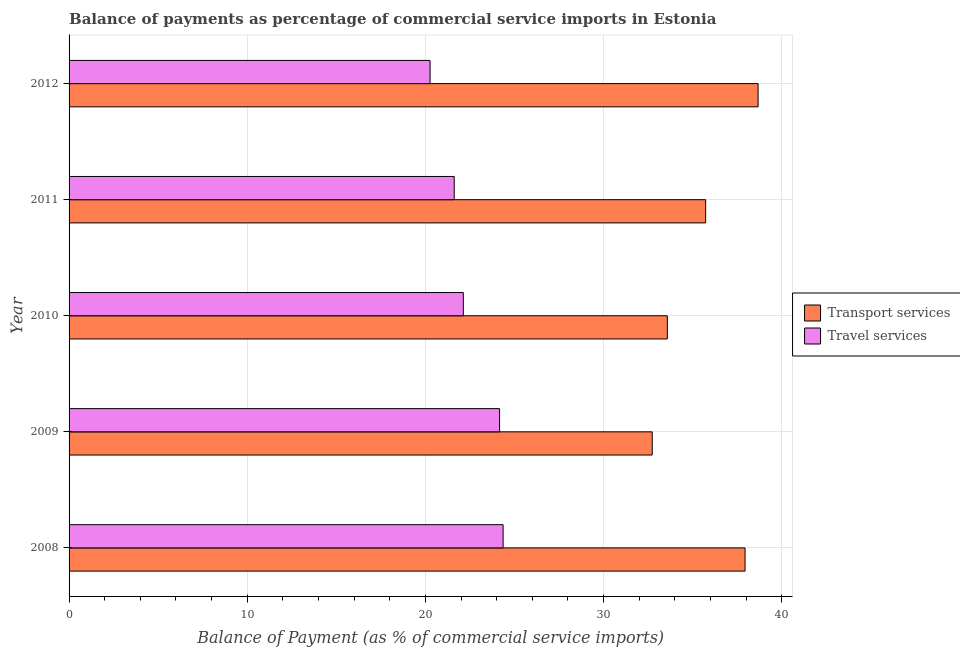Are the number of bars per tick equal to the number of legend labels?
Provide a succinct answer. Yes. How many bars are there on the 3rd tick from the top?
Offer a terse response. 2. How many bars are there on the 3rd tick from the bottom?
Your response must be concise. 2. What is the label of the 5th group of bars from the top?
Keep it short and to the point. 2008. What is the balance of payments of transport services in 2011?
Give a very brief answer. 35.73. Across all years, what is the maximum balance of payments of travel services?
Your answer should be very brief. 24.36. Across all years, what is the minimum balance of payments of travel services?
Ensure brevity in your answer.  20.26. What is the total balance of payments of travel services in the graph?
Your answer should be very brief. 112.52. What is the difference between the balance of payments of transport services in 2008 and that in 2011?
Offer a terse response. 2.21. What is the difference between the balance of payments of travel services in 2011 and the balance of payments of transport services in 2012?
Make the answer very short. -17.06. What is the average balance of payments of transport services per year?
Your answer should be very brief. 35.73. In the year 2011, what is the difference between the balance of payments of transport services and balance of payments of travel services?
Ensure brevity in your answer.  14.11. In how many years, is the balance of payments of transport services greater than 32 %?
Your answer should be very brief. 5. Is the balance of payments of travel services in 2008 less than that in 2012?
Your response must be concise. No. Is the difference between the balance of payments of transport services in 2010 and 2011 greater than the difference between the balance of payments of travel services in 2010 and 2011?
Provide a succinct answer. No. What is the difference between the highest and the second highest balance of payments of transport services?
Ensure brevity in your answer.  0.73. In how many years, is the balance of payments of transport services greater than the average balance of payments of transport services taken over all years?
Your response must be concise. 2. Is the sum of the balance of payments of transport services in 2009 and 2010 greater than the maximum balance of payments of travel services across all years?
Your response must be concise. Yes. What does the 2nd bar from the top in 2008 represents?
Provide a short and direct response. Transport services. What does the 1st bar from the bottom in 2012 represents?
Your response must be concise. Transport services. How many bars are there?
Make the answer very short. 10. Are all the bars in the graph horizontal?
Your answer should be very brief. Yes. What is the difference between two consecutive major ticks on the X-axis?
Offer a terse response. 10. Are the values on the major ticks of X-axis written in scientific E-notation?
Keep it short and to the point. No. Does the graph contain any zero values?
Keep it short and to the point. No. How are the legend labels stacked?
Make the answer very short. Vertical. What is the title of the graph?
Offer a terse response. Balance of payments as percentage of commercial service imports in Estonia. Does "External balance on goods" appear as one of the legend labels in the graph?
Provide a short and direct response. No. What is the label or title of the X-axis?
Ensure brevity in your answer.  Balance of Payment (as % of commercial service imports). What is the Balance of Payment (as % of commercial service imports) of Transport services in 2008?
Your response must be concise. 37.94. What is the Balance of Payment (as % of commercial service imports) of Travel services in 2008?
Your response must be concise. 24.36. What is the Balance of Payment (as % of commercial service imports) in Transport services in 2009?
Your answer should be very brief. 32.73. What is the Balance of Payment (as % of commercial service imports) of Travel services in 2009?
Ensure brevity in your answer.  24.16. What is the Balance of Payment (as % of commercial service imports) in Transport services in 2010?
Ensure brevity in your answer.  33.58. What is the Balance of Payment (as % of commercial service imports) of Travel services in 2010?
Your response must be concise. 22.13. What is the Balance of Payment (as % of commercial service imports) in Transport services in 2011?
Provide a succinct answer. 35.73. What is the Balance of Payment (as % of commercial service imports) in Travel services in 2011?
Your answer should be very brief. 21.62. What is the Balance of Payment (as % of commercial service imports) of Transport services in 2012?
Your answer should be compact. 38.67. What is the Balance of Payment (as % of commercial service imports) in Travel services in 2012?
Your answer should be very brief. 20.26. Across all years, what is the maximum Balance of Payment (as % of commercial service imports) of Transport services?
Provide a succinct answer. 38.67. Across all years, what is the maximum Balance of Payment (as % of commercial service imports) in Travel services?
Give a very brief answer. 24.36. Across all years, what is the minimum Balance of Payment (as % of commercial service imports) of Transport services?
Offer a very short reply. 32.73. Across all years, what is the minimum Balance of Payment (as % of commercial service imports) in Travel services?
Keep it short and to the point. 20.26. What is the total Balance of Payment (as % of commercial service imports) in Transport services in the graph?
Offer a very short reply. 178.64. What is the total Balance of Payment (as % of commercial service imports) of Travel services in the graph?
Keep it short and to the point. 112.52. What is the difference between the Balance of Payment (as % of commercial service imports) of Transport services in 2008 and that in 2009?
Offer a very short reply. 5.21. What is the difference between the Balance of Payment (as % of commercial service imports) in Travel services in 2008 and that in 2009?
Ensure brevity in your answer.  0.2. What is the difference between the Balance of Payment (as % of commercial service imports) of Transport services in 2008 and that in 2010?
Ensure brevity in your answer.  4.36. What is the difference between the Balance of Payment (as % of commercial service imports) of Travel services in 2008 and that in 2010?
Keep it short and to the point. 2.23. What is the difference between the Balance of Payment (as % of commercial service imports) of Transport services in 2008 and that in 2011?
Provide a short and direct response. 2.21. What is the difference between the Balance of Payment (as % of commercial service imports) of Travel services in 2008 and that in 2011?
Keep it short and to the point. 2.75. What is the difference between the Balance of Payment (as % of commercial service imports) in Transport services in 2008 and that in 2012?
Give a very brief answer. -0.73. What is the difference between the Balance of Payment (as % of commercial service imports) of Transport services in 2009 and that in 2010?
Ensure brevity in your answer.  -0.85. What is the difference between the Balance of Payment (as % of commercial service imports) of Travel services in 2009 and that in 2010?
Provide a succinct answer. 2.03. What is the difference between the Balance of Payment (as % of commercial service imports) in Transport services in 2009 and that in 2011?
Ensure brevity in your answer.  -3. What is the difference between the Balance of Payment (as % of commercial service imports) of Travel services in 2009 and that in 2011?
Offer a terse response. 2.55. What is the difference between the Balance of Payment (as % of commercial service imports) of Transport services in 2009 and that in 2012?
Make the answer very short. -5.94. What is the difference between the Balance of Payment (as % of commercial service imports) of Travel services in 2009 and that in 2012?
Make the answer very short. 3.9. What is the difference between the Balance of Payment (as % of commercial service imports) of Transport services in 2010 and that in 2011?
Your response must be concise. -2.15. What is the difference between the Balance of Payment (as % of commercial service imports) of Travel services in 2010 and that in 2011?
Provide a succinct answer. 0.51. What is the difference between the Balance of Payment (as % of commercial service imports) in Transport services in 2010 and that in 2012?
Give a very brief answer. -5.09. What is the difference between the Balance of Payment (as % of commercial service imports) of Travel services in 2010 and that in 2012?
Your response must be concise. 1.87. What is the difference between the Balance of Payment (as % of commercial service imports) in Transport services in 2011 and that in 2012?
Make the answer very short. -2.94. What is the difference between the Balance of Payment (as % of commercial service imports) of Travel services in 2011 and that in 2012?
Provide a succinct answer. 1.35. What is the difference between the Balance of Payment (as % of commercial service imports) in Transport services in 2008 and the Balance of Payment (as % of commercial service imports) in Travel services in 2009?
Offer a very short reply. 13.78. What is the difference between the Balance of Payment (as % of commercial service imports) of Transport services in 2008 and the Balance of Payment (as % of commercial service imports) of Travel services in 2010?
Your answer should be very brief. 15.81. What is the difference between the Balance of Payment (as % of commercial service imports) of Transport services in 2008 and the Balance of Payment (as % of commercial service imports) of Travel services in 2011?
Offer a terse response. 16.32. What is the difference between the Balance of Payment (as % of commercial service imports) of Transport services in 2008 and the Balance of Payment (as % of commercial service imports) of Travel services in 2012?
Offer a terse response. 17.68. What is the difference between the Balance of Payment (as % of commercial service imports) in Transport services in 2009 and the Balance of Payment (as % of commercial service imports) in Travel services in 2010?
Ensure brevity in your answer.  10.6. What is the difference between the Balance of Payment (as % of commercial service imports) in Transport services in 2009 and the Balance of Payment (as % of commercial service imports) in Travel services in 2011?
Provide a short and direct response. 11.11. What is the difference between the Balance of Payment (as % of commercial service imports) in Transport services in 2009 and the Balance of Payment (as % of commercial service imports) in Travel services in 2012?
Your answer should be compact. 12.47. What is the difference between the Balance of Payment (as % of commercial service imports) in Transport services in 2010 and the Balance of Payment (as % of commercial service imports) in Travel services in 2011?
Offer a terse response. 11.96. What is the difference between the Balance of Payment (as % of commercial service imports) in Transport services in 2010 and the Balance of Payment (as % of commercial service imports) in Travel services in 2012?
Provide a short and direct response. 13.32. What is the difference between the Balance of Payment (as % of commercial service imports) in Transport services in 2011 and the Balance of Payment (as % of commercial service imports) in Travel services in 2012?
Provide a short and direct response. 15.47. What is the average Balance of Payment (as % of commercial service imports) of Transport services per year?
Keep it short and to the point. 35.73. What is the average Balance of Payment (as % of commercial service imports) of Travel services per year?
Make the answer very short. 22.5. In the year 2008, what is the difference between the Balance of Payment (as % of commercial service imports) of Transport services and Balance of Payment (as % of commercial service imports) of Travel services?
Provide a succinct answer. 13.58. In the year 2009, what is the difference between the Balance of Payment (as % of commercial service imports) of Transport services and Balance of Payment (as % of commercial service imports) of Travel services?
Ensure brevity in your answer.  8.57. In the year 2010, what is the difference between the Balance of Payment (as % of commercial service imports) of Transport services and Balance of Payment (as % of commercial service imports) of Travel services?
Provide a succinct answer. 11.45. In the year 2011, what is the difference between the Balance of Payment (as % of commercial service imports) of Transport services and Balance of Payment (as % of commercial service imports) of Travel services?
Offer a terse response. 14.11. In the year 2012, what is the difference between the Balance of Payment (as % of commercial service imports) in Transport services and Balance of Payment (as % of commercial service imports) in Travel services?
Your answer should be very brief. 18.41. What is the ratio of the Balance of Payment (as % of commercial service imports) of Transport services in 2008 to that in 2009?
Make the answer very short. 1.16. What is the ratio of the Balance of Payment (as % of commercial service imports) in Travel services in 2008 to that in 2009?
Provide a short and direct response. 1.01. What is the ratio of the Balance of Payment (as % of commercial service imports) in Transport services in 2008 to that in 2010?
Your answer should be very brief. 1.13. What is the ratio of the Balance of Payment (as % of commercial service imports) of Travel services in 2008 to that in 2010?
Your answer should be very brief. 1.1. What is the ratio of the Balance of Payment (as % of commercial service imports) of Transport services in 2008 to that in 2011?
Offer a terse response. 1.06. What is the ratio of the Balance of Payment (as % of commercial service imports) in Travel services in 2008 to that in 2011?
Offer a very short reply. 1.13. What is the ratio of the Balance of Payment (as % of commercial service imports) of Transport services in 2008 to that in 2012?
Offer a terse response. 0.98. What is the ratio of the Balance of Payment (as % of commercial service imports) of Travel services in 2008 to that in 2012?
Offer a very short reply. 1.2. What is the ratio of the Balance of Payment (as % of commercial service imports) in Transport services in 2009 to that in 2010?
Provide a succinct answer. 0.97. What is the ratio of the Balance of Payment (as % of commercial service imports) of Travel services in 2009 to that in 2010?
Ensure brevity in your answer.  1.09. What is the ratio of the Balance of Payment (as % of commercial service imports) in Transport services in 2009 to that in 2011?
Offer a very short reply. 0.92. What is the ratio of the Balance of Payment (as % of commercial service imports) of Travel services in 2009 to that in 2011?
Give a very brief answer. 1.12. What is the ratio of the Balance of Payment (as % of commercial service imports) in Transport services in 2009 to that in 2012?
Your response must be concise. 0.85. What is the ratio of the Balance of Payment (as % of commercial service imports) of Travel services in 2009 to that in 2012?
Your answer should be very brief. 1.19. What is the ratio of the Balance of Payment (as % of commercial service imports) of Transport services in 2010 to that in 2011?
Make the answer very short. 0.94. What is the ratio of the Balance of Payment (as % of commercial service imports) of Travel services in 2010 to that in 2011?
Ensure brevity in your answer.  1.02. What is the ratio of the Balance of Payment (as % of commercial service imports) in Transport services in 2010 to that in 2012?
Give a very brief answer. 0.87. What is the ratio of the Balance of Payment (as % of commercial service imports) in Travel services in 2010 to that in 2012?
Provide a short and direct response. 1.09. What is the ratio of the Balance of Payment (as % of commercial service imports) of Transport services in 2011 to that in 2012?
Ensure brevity in your answer.  0.92. What is the ratio of the Balance of Payment (as % of commercial service imports) in Travel services in 2011 to that in 2012?
Provide a short and direct response. 1.07. What is the difference between the highest and the second highest Balance of Payment (as % of commercial service imports) in Transport services?
Ensure brevity in your answer.  0.73. What is the difference between the highest and the second highest Balance of Payment (as % of commercial service imports) of Travel services?
Offer a terse response. 0.2. What is the difference between the highest and the lowest Balance of Payment (as % of commercial service imports) in Transport services?
Your answer should be compact. 5.94. 